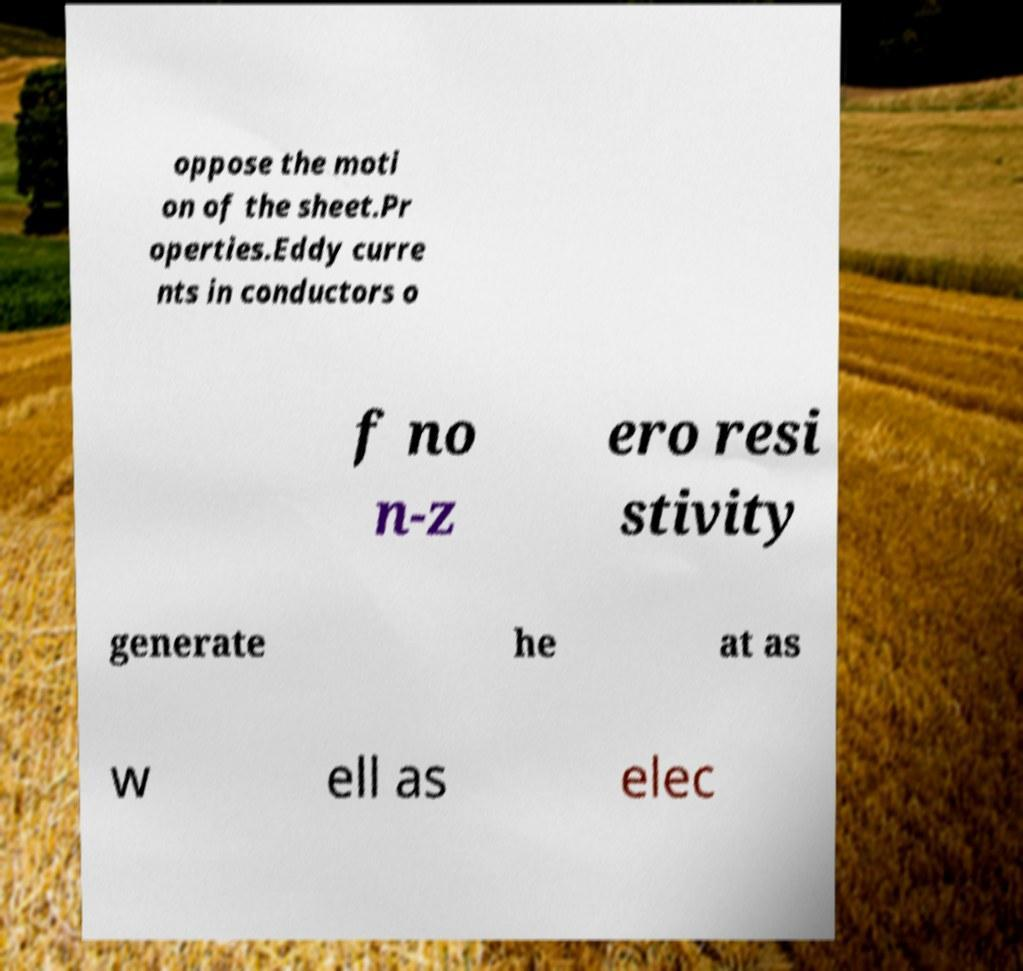For documentation purposes, I need the text within this image transcribed. Could you provide that? oppose the moti on of the sheet.Pr operties.Eddy curre nts in conductors o f no n-z ero resi stivity generate he at as w ell as elec 